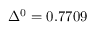<formula> <loc_0><loc_0><loc_500><loc_500>\Delta ^ { 0 } = 0 . 7 7 0 9</formula> 